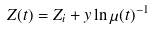Convert formula to latex. <formula><loc_0><loc_0><loc_500><loc_500>Z ( t ) = Z _ { i } + y \ln \mu ( t ) ^ { - 1 }</formula> 